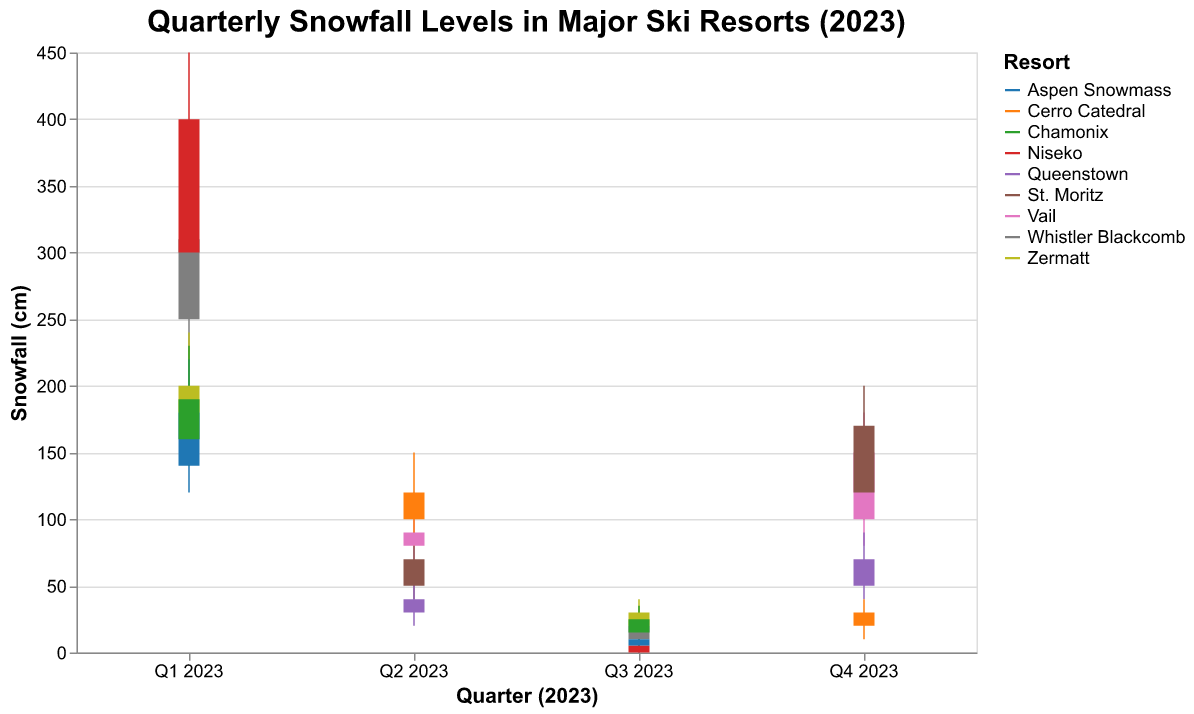What's the title of the figure? The title is often placed at the top of the chart and summarizes what the figure is about. Here, it’s centered and reads “Quarterly Snowfall Levels in Major Ski Resorts (2023)”
Answer: Quarterly Snowfall Levels in Major Ski Resorts (2023) What is the range of snowfall amounts for Niseko in Q1 2023? An OHLC chart shows the range using vertical lines. For Niseko in Q1 2023, it ranges from the Low value of 280 cm to the High value of 450 cm.
Answer: 280 - 450 cm Which resort had the highest closing snowfall level in Q4 2023? The "Close" point is typically marked toward the right end of each bar. By inspecting Q4 2023, St. Moritz has the highest Close value of 170 cm.
Answer: St. Moritz What is the change in snowfall for Whistler Blackcomb from Q1 2023 to Q3 2023 based on the closing values? By comparing the Close value of Q1 2023 (310 cm) with the Close value of Q3 2023 (20 cm), we see a change of 310 - 20 = 290 cm.
Answer: 290 cm decrease Which quarter had the highest variability in snowfall levels for any resort, and which resort was it? Variability can be identified by the length of the vertical lines in the chart. The most extended line appears in Q1 2023 for Niseko, with a range of 450 - 280 = 170 cm.
Answer: Q1 2023, Niseko How does the opening snowfall level of Vail in Q4 2023 compare to its opening level in Q2 2023? By comparing the opening values: Q4 2023 (100 cm) and Q2 2023 (80 cm), it shows that Q4 2023 is higher by 100 - 80 = 20 cm.
Answer: 20 cm higher What is the sum of the closing snowfall levels for all resorts in Q1 2023? Summing up the Close values: 310 (Whistler Blackcomb) + 200 (Zermatt) + 180 (Aspen Snowmass) + 400 (Niseko) + 190 (Chamonix) = 1280 cm.
Answer: 1280 cm Which resort had the lowest high snowfall level in Q2 2023? By examining the High values for Q2 2023, Queenstown has the lowest high at 60 cm.
Answer: Queenstown How many resorts have a higher closing snowfall level in Q4 2023 than Vail's opening level in Q2 2023? Vail's opening in Q2 2023 is 80 cm. In Q4 2023, the closing levels are: 150 (Vail), 170 (St. Moritz), 70 (Queenstown), 30 (Cerro Catedral). Two resorts (Vail and St. Moritz) have higher values.
Answer: 2 What is the average high snowfall level for all resorts in Q3 2023? The high values for Q3 2023 are: 30 (Whistler Blackcomb), 40 (Zermatt), 15 (Aspen Snowmass), 10 (Niseko), 35 (Chamonix). The sum is 30 + 40 + 15 + 10 + 35 = 130, and the average is 130 / 5 = 26 cm.
Answer: 26 cm 